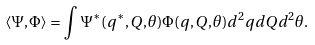Convert formula to latex. <formula><loc_0><loc_0><loc_500><loc_500>\langle \Psi , \Phi \rangle = \int \Psi ^ { * } ( q ^ { * } , Q , \theta ) \Phi ( q , Q , \theta ) d ^ { 2 } q d Q d ^ { 2 } \theta .</formula> 